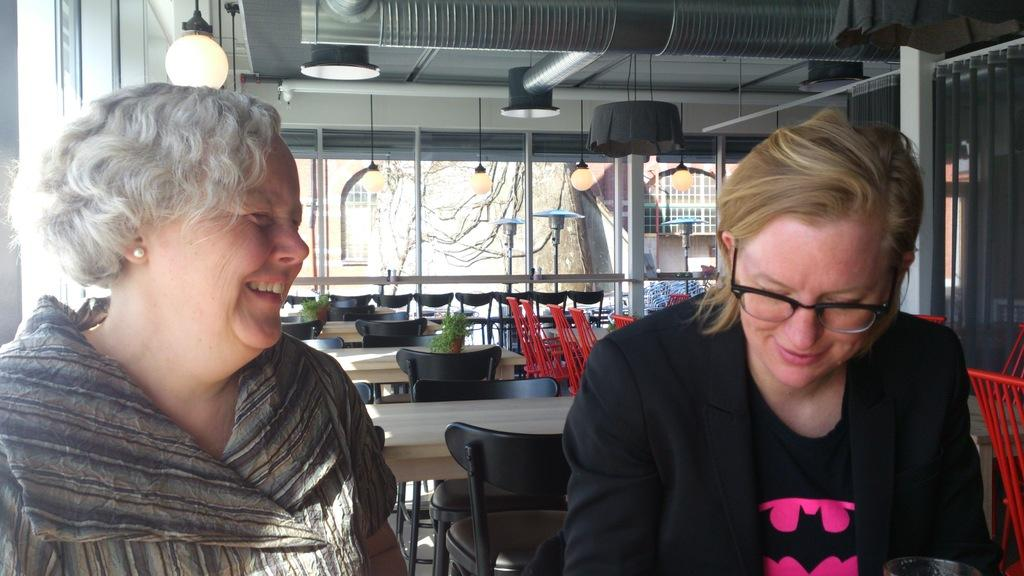How many people are in the image? There are two people in the image. What type of furniture is present in the image? There are chairs and tables in the image. What can be seen through the windows in the image? There is a building and trees visible outside the windows. What type of reward is being given to the flock of birds outside the window? There are no birds or rewards present in the image. How do the people in the image say good-bye to each other? The image does not show the people interacting or saying good-bye to each other. 